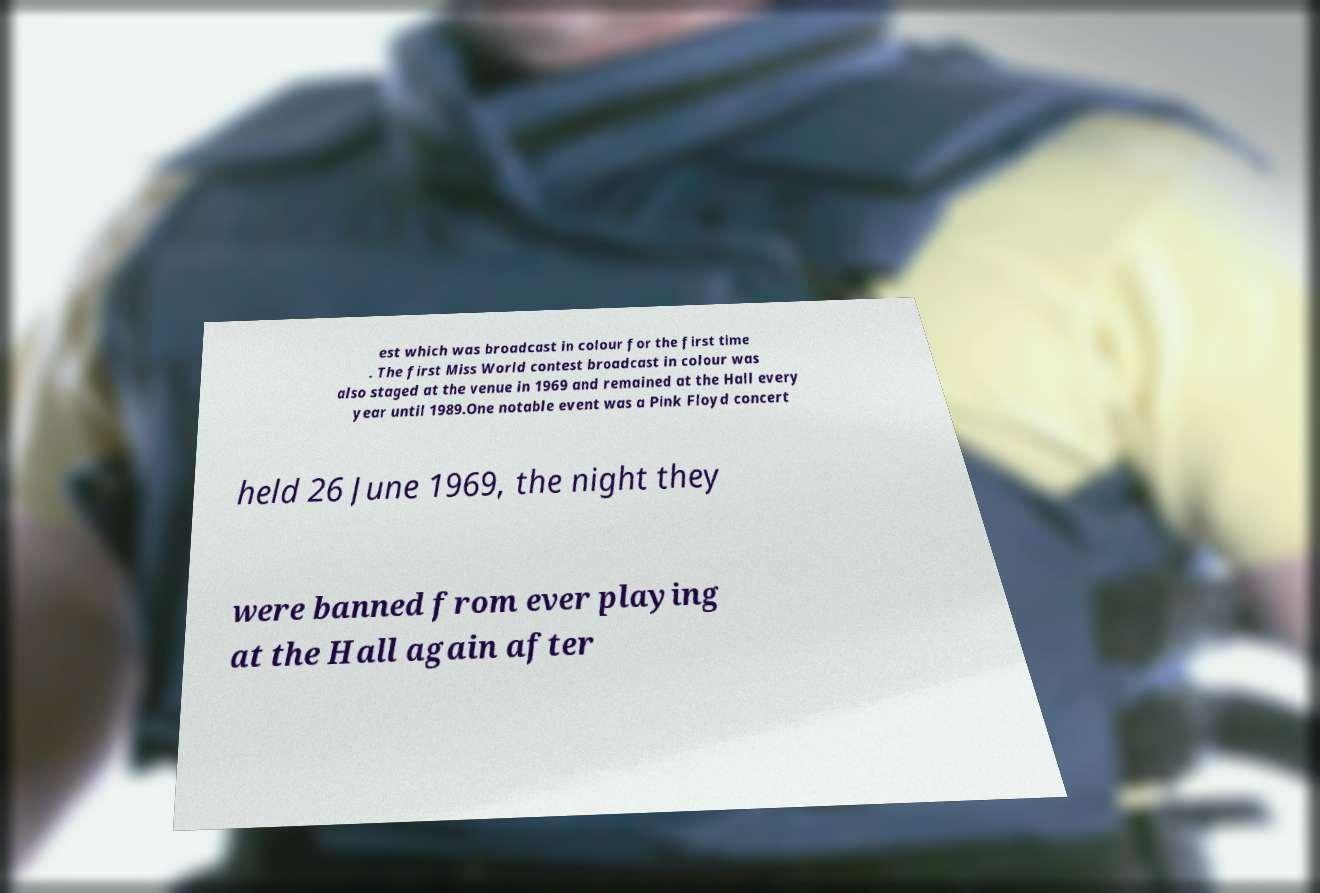Please read and relay the text visible in this image. What does it say? est which was broadcast in colour for the first time . The first Miss World contest broadcast in colour was also staged at the venue in 1969 and remained at the Hall every year until 1989.One notable event was a Pink Floyd concert held 26 June 1969, the night they were banned from ever playing at the Hall again after 